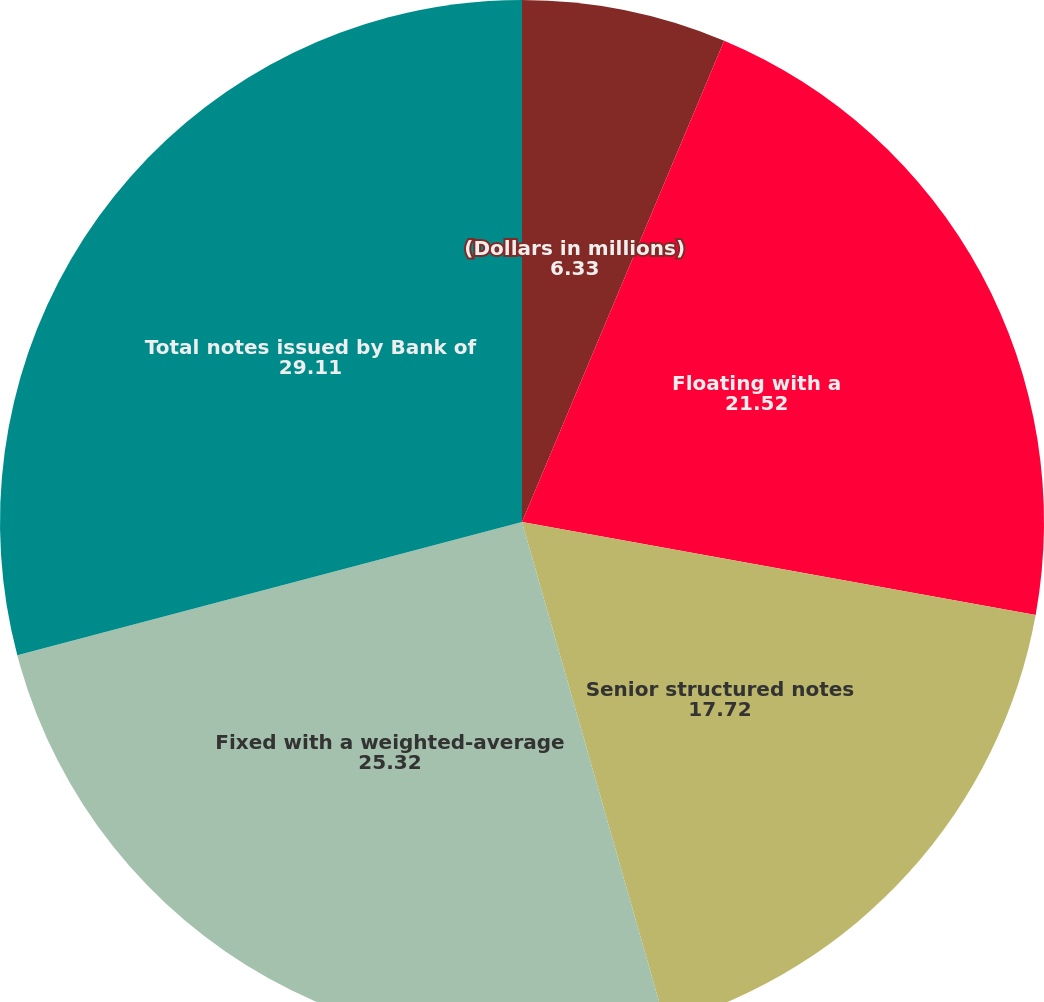Convert chart. <chart><loc_0><loc_0><loc_500><loc_500><pie_chart><fcel>(Dollars in millions)<fcel>Floating with a<fcel>Senior structured notes<fcel>Fixed with a weighted-average<fcel>Total notes issued by Bank of<nl><fcel>6.33%<fcel>21.52%<fcel>17.72%<fcel>25.32%<fcel>29.11%<nl></chart> 